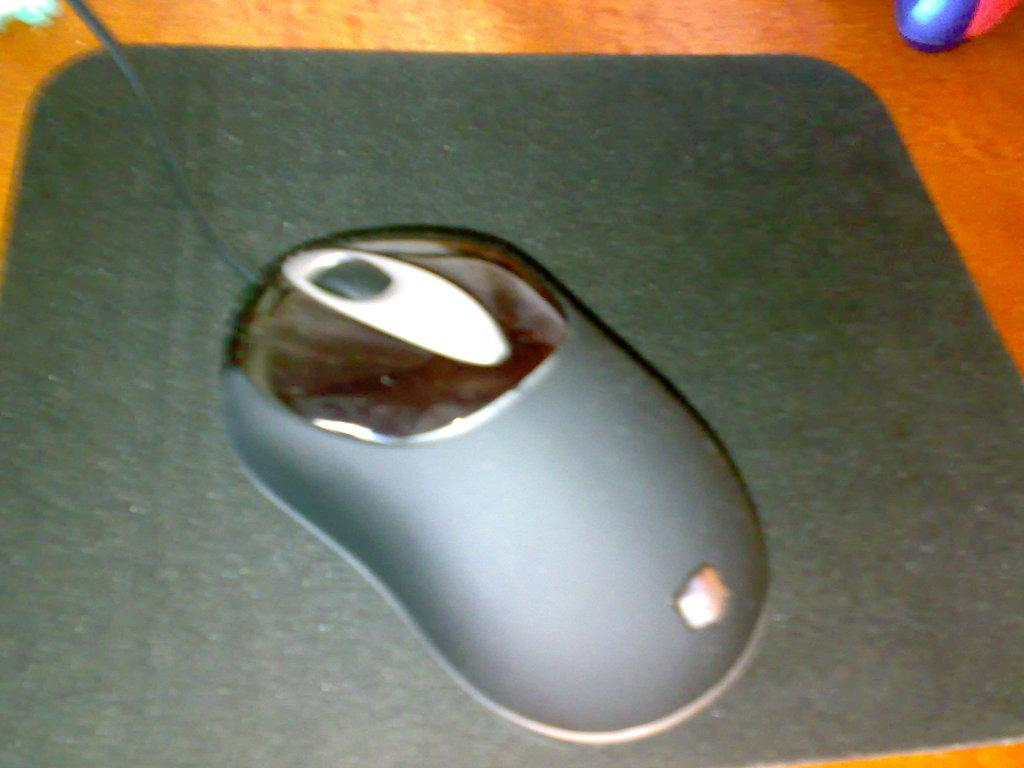What is the main subject in the center of the image? There is a mouse in the center of the image. What is the mouse placed on? The mouse is placed on a mouse pad. What type of surface can be seen in the background of the image? There is a wooden table in the background of the image. What other objects can be seen in the background of the image? There are other objects visible in the background of the image. What is the name of the month in which the mouse is celebrating its birthday in the image? There is no indication of a birthday or a specific month in the image, so this information cannot be determined. 